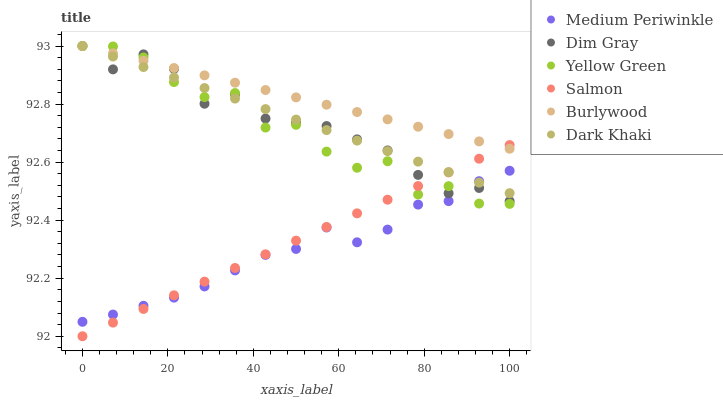Does Medium Periwinkle have the minimum area under the curve?
Answer yes or no. Yes. Does Burlywood have the maximum area under the curve?
Answer yes or no. Yes. Does Yellow Green have the minimum area under the curve?
Answer yes or no. No. Does Yellow Green have the maximum area under the curve?
Answer yes or no. No. Is Salmon the smoothest?
Answer yes or no. Yes. Is Yellow Green the roughest?
Answer yes or no. Yes. Is Burlywood the smoothest?
Answer yes or no. No. Is Burlywood the roughest?
Answer yes or no. No. Does Salmon have the lowest value?
Answer yes or no. Yes. Does Yellow Green have the lowest value?
Answer yes or no. No. Does Dark Khaki have the highest value?
Answer yes or no. Yes. Does Medium Periwinkle have the highest value?
Answer yes or no. No. Is Medium Periwinkle less than Burlywood?
Answer yes or no. Yes. Is Burlywood greater than Medium Periwinkle?
Answer yes or no. Yes. Does Yellow Green intersect Dark Khaki?
Answer yes or no. Yes. Is Yellow Green less than Dark Khaki?
Answer yes or no. No. Is Yellow Green greater than Dark Khaki?
Answer yes or no. No. Does Medium Periwinkle intersect Burlywood?
Answer yes or no. No. 